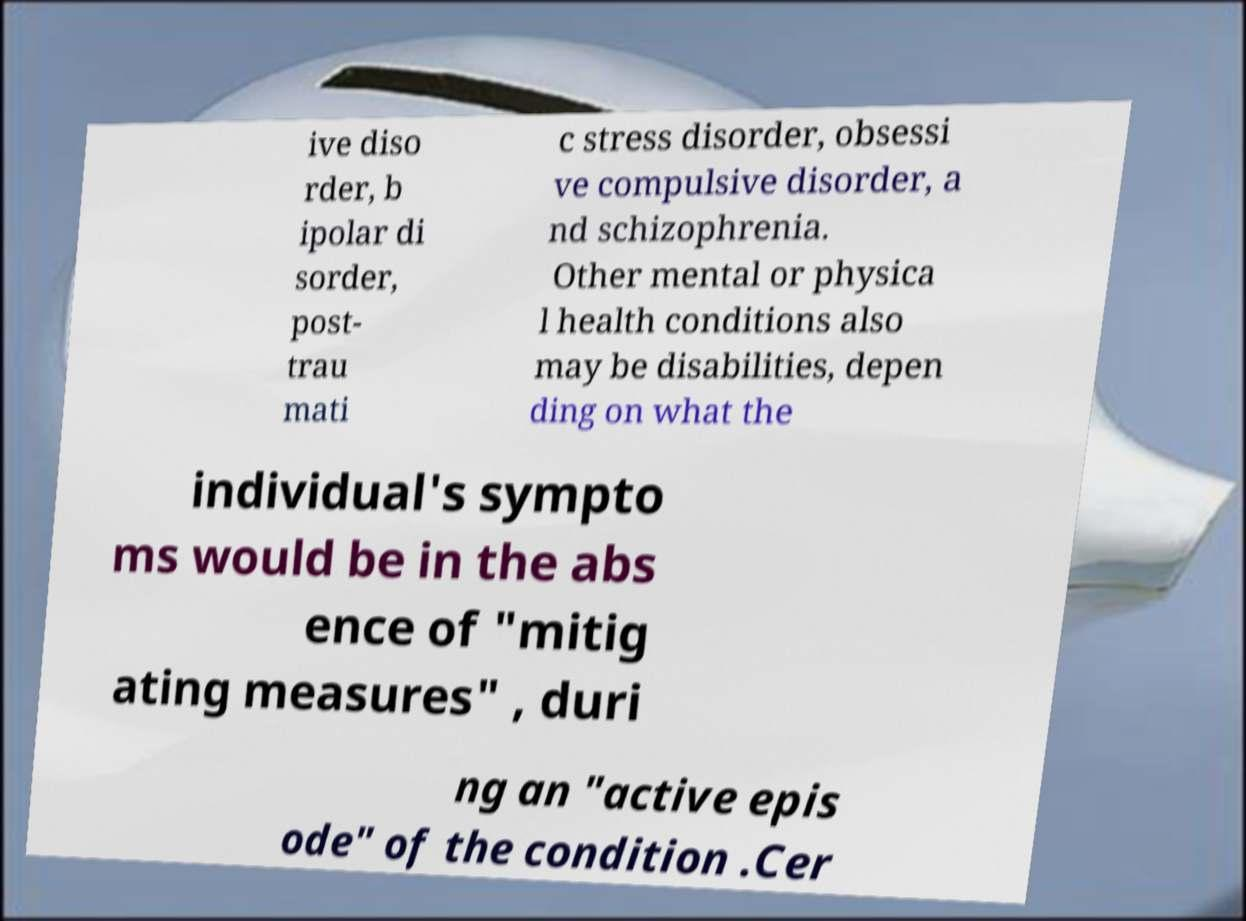What messages or text are displayed in this image? I need them in a readable, typed format. ive diso rder, b ipolar di sorder, post- trau mati c stress disorder, obsessi ve compulsive disorder, a nd schizophrenia. Other mental or physica l health conditions also may be disabilities, depen ding on what the individual's sympto ms would be in the abs ence of "mitig ating measures" , duri ng an "active epis ode" of the condition .Cer 